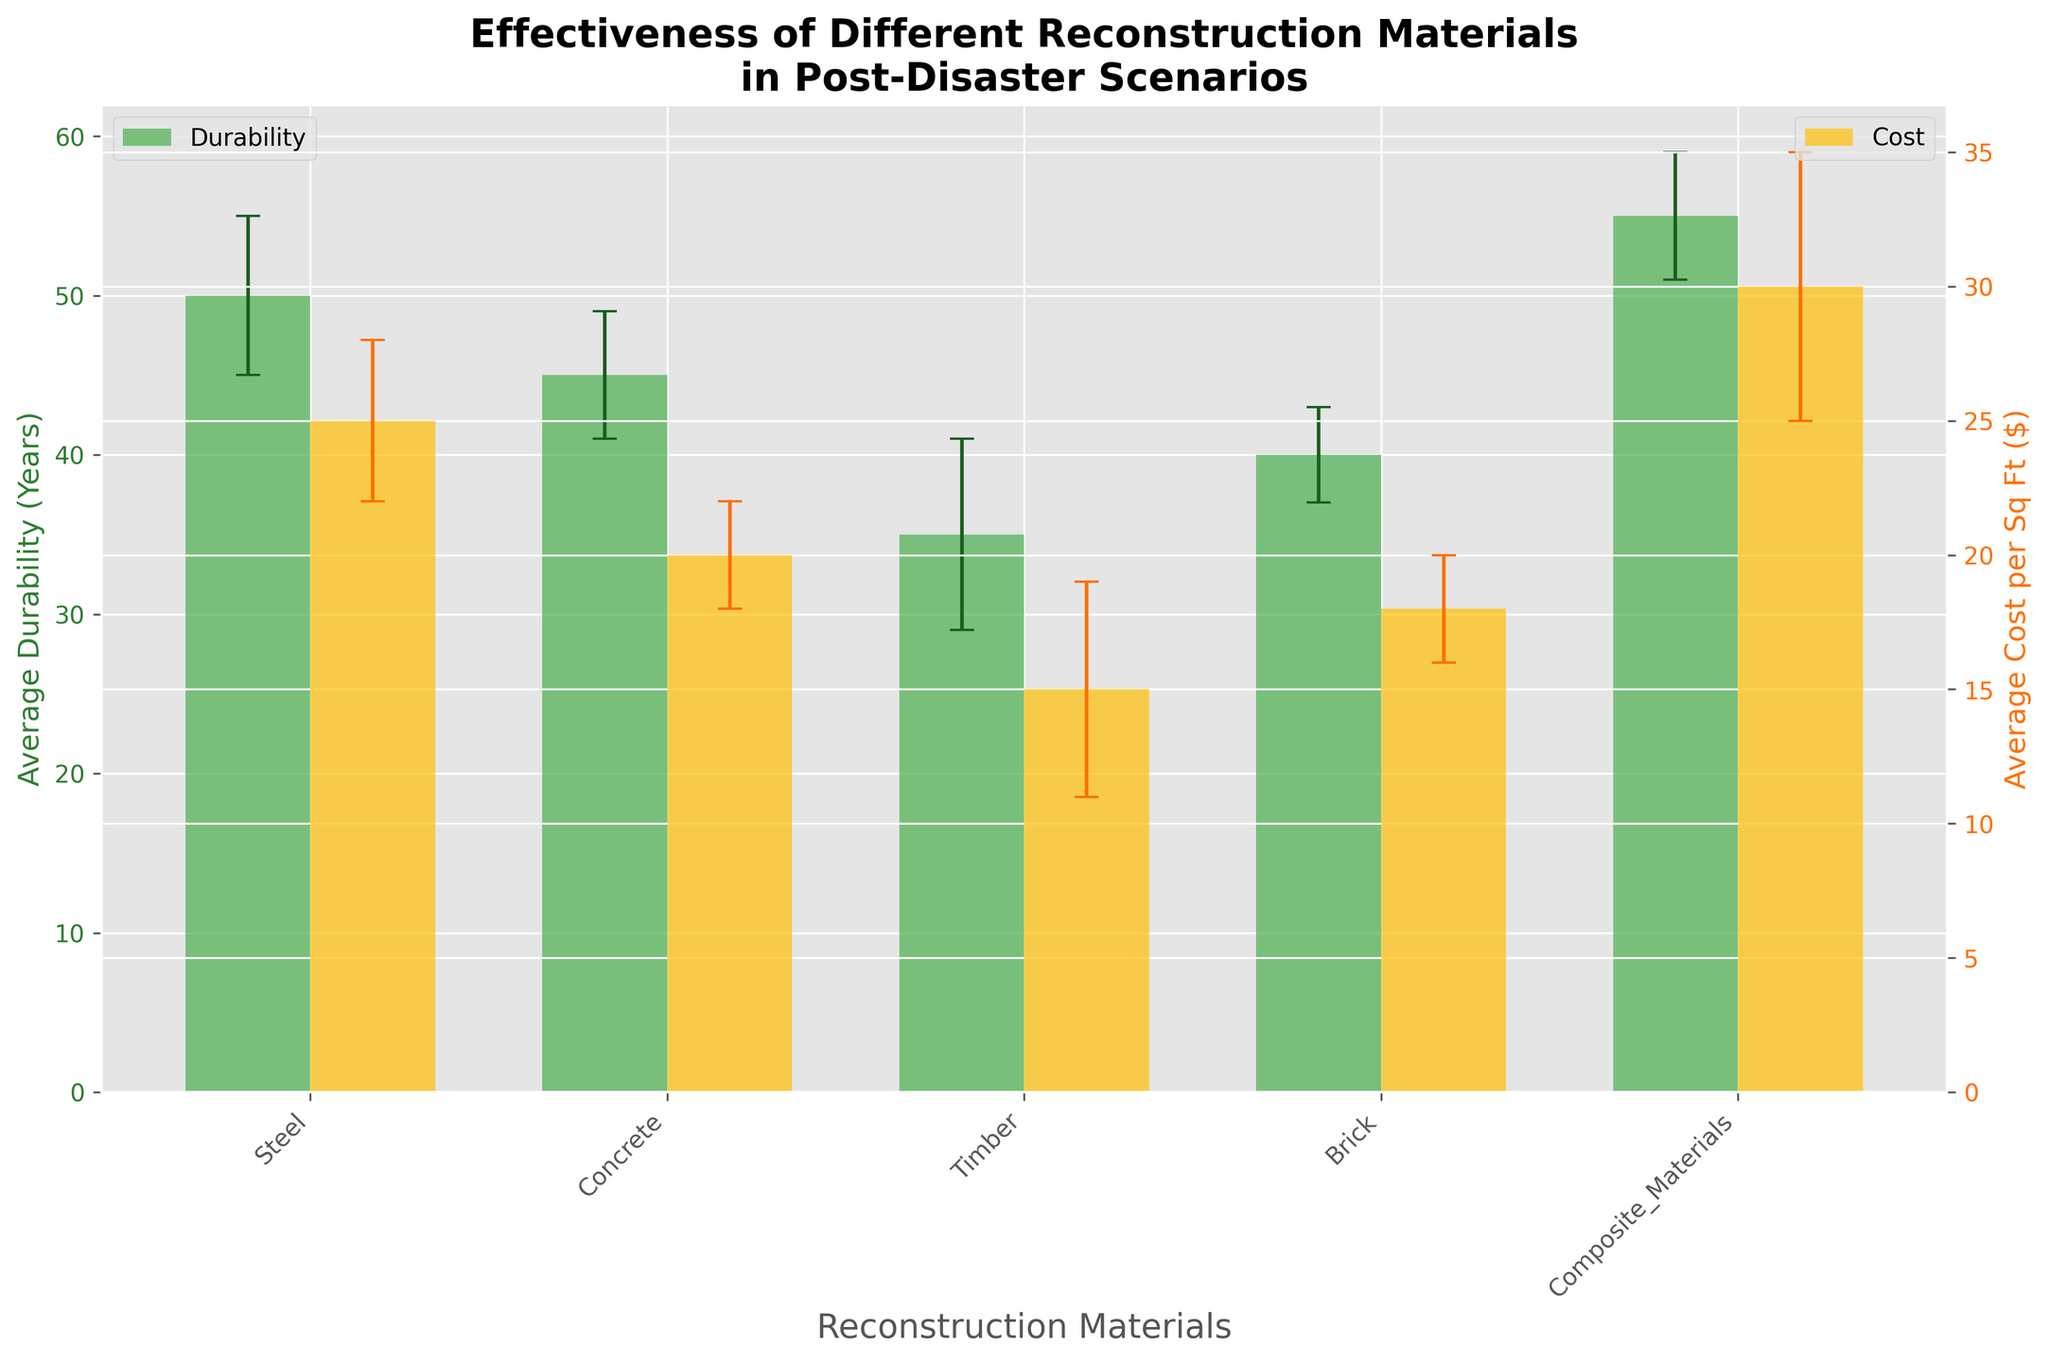Which material has the highest average durability? The material with the highest average durability is identified by looking for the highest bar in the durability set.
Answer: Composite Materials Which material has the lowest average cost per square foot? The material with the lowest average cost per square foot is identified by looking for the lowest bar in the cost set.
Answer: Timber What is the range of average durability years for the materials shown? The range is calculated as the difference between the highest and lowest average durability years. Composite Materials have the highest average durability of 55 years, and Timber has the lowest at 35 years. Hence, the range is 55 - 35.
Answer: 20 years How does the average cost per square foot of Steel compare to that of Brick? To compare, look at the heights of the bars in the cost section for Steel and Brick. Steel costs $25 per sq ft, while Brick costs $18 per sq ft. The difference is 25 - 18.
Answer: Steel is $7 more expensive Which two materials have the closest average durability? Find the two bars in the durability set with the most similar heights. Concrete has 45 years, and Brick has 40 years; the difference is 5 years, which is the smallest difference between any two materials.
Answer: Concrete and Brick Considering the error bars, which material shows the highest variation in cost? The highest variation in cost is identified by the longest error bar in the cost section. Composite Materials have a cost standard deviation of 5, which is the highest among the materials.
Answer: Composite Materials Is there any material whose standard deviation in durability and cost are both within two units? Look for materials where both the error bars in the durability and cost sections are fairly small and within 2 units. Brick has a durability standard deviation of 3 and a cost standard deviation of 2, but no material has both deviations within two units.
Answer: No How does the standard deviation in durability of Timber compare to that of Steel? Compare the height of the error bars in the durability section for Timber and Steel. Timber has a standard deviation of 6 years, while Steel has a standard deviation of 5 years.
Answer: Timber's standard deviation is higher by 1 year Which material is more cost-effective considering both durability and cost: Concrete or Timber? Comparing both metrics, Concrete has higher durability (45 years vs. 35 years) and a moderate cost ($20 vs. $15 per sq ft). Durability per dollar for Concrete: 45/20 = 2.25 years/sq ft; for Timber: 35/15 = 2.33 years/sq ft. Timber is slightly more cost-effective.
Answer: Timber How does the average durability-to-cost ratio of Composite Materials compare to that of Steel? Calculate the durability-to-cost ratio: Composite Materials: 55 years / $30 per sq ft = 1.83 years/sq ft; Steel: 50 years / $25 per sq ft = 2.00 years/sq ft. Compare the two values.
Answer: Steel has a higher ratio 